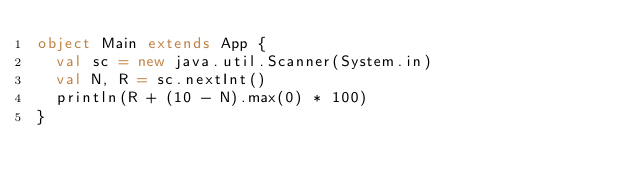<code> <loc_0><loc_0><loc_500><loc_500><_Scala_>object Main extends App {
  val sc = new java.util.Scanner(System.in)
  val N, R = sc.nextInt()
  println(R + (10 - N).max(0) * 100)
}
</code> 